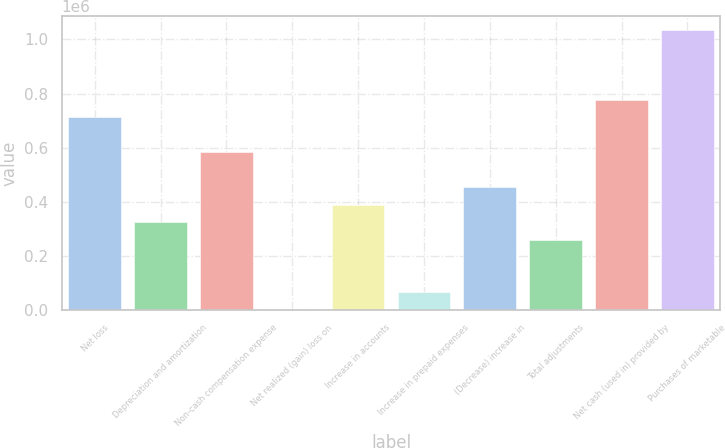Convert chart. <chart><loc_0><loc_0><loc_500><loc_500><bar_chart><fcel>Net loss<fcel>Depreciation and amortization<fcel>Non-cash compensation expense<fcel>Net realized (gain) loss on<fcel>Increase in accounts<fcel>Increase in prepaid expenses<fcel>(Decrease) increase in<fcel>Total adjustments<fcel>Net cash (used in) provided by<fcel>Purchases of marketable<nl><fcel>711416<fcel>324086<fcel>582306<fcel>1310<fcel>388641<fcel>65865.1<fcel>453196<fcel>259530<fcel>775971<fcel>1.03419e+06<nl></chart> 